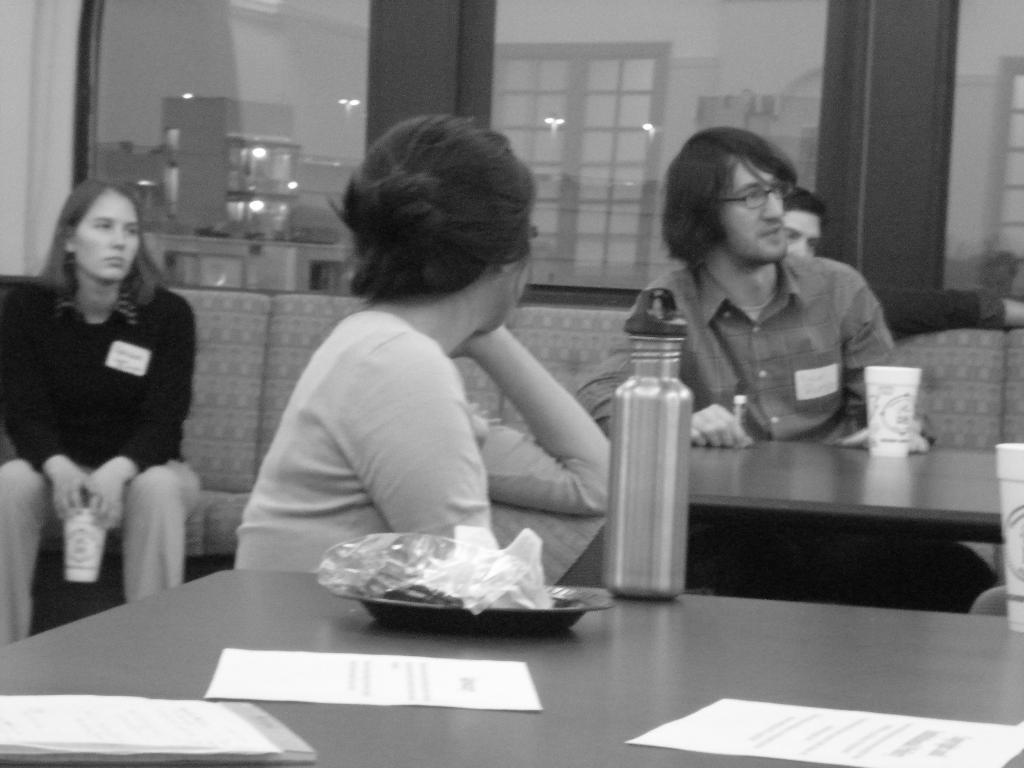Describe this image in one or two sentences. In this image i can see a group of people are sitting on a couch in front of a table. On the table we have few objects on it. 